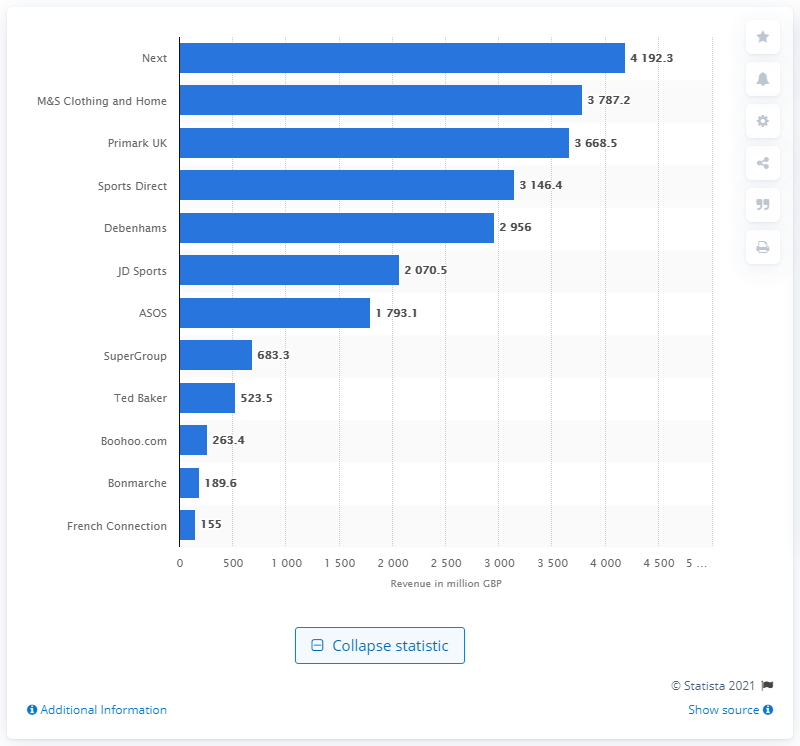Identify some key points in this picture. In 2017, the revenue of the largest public apparel retailer in the United Kingdom was estimated to be approximately 4,192.3 million pounds. 